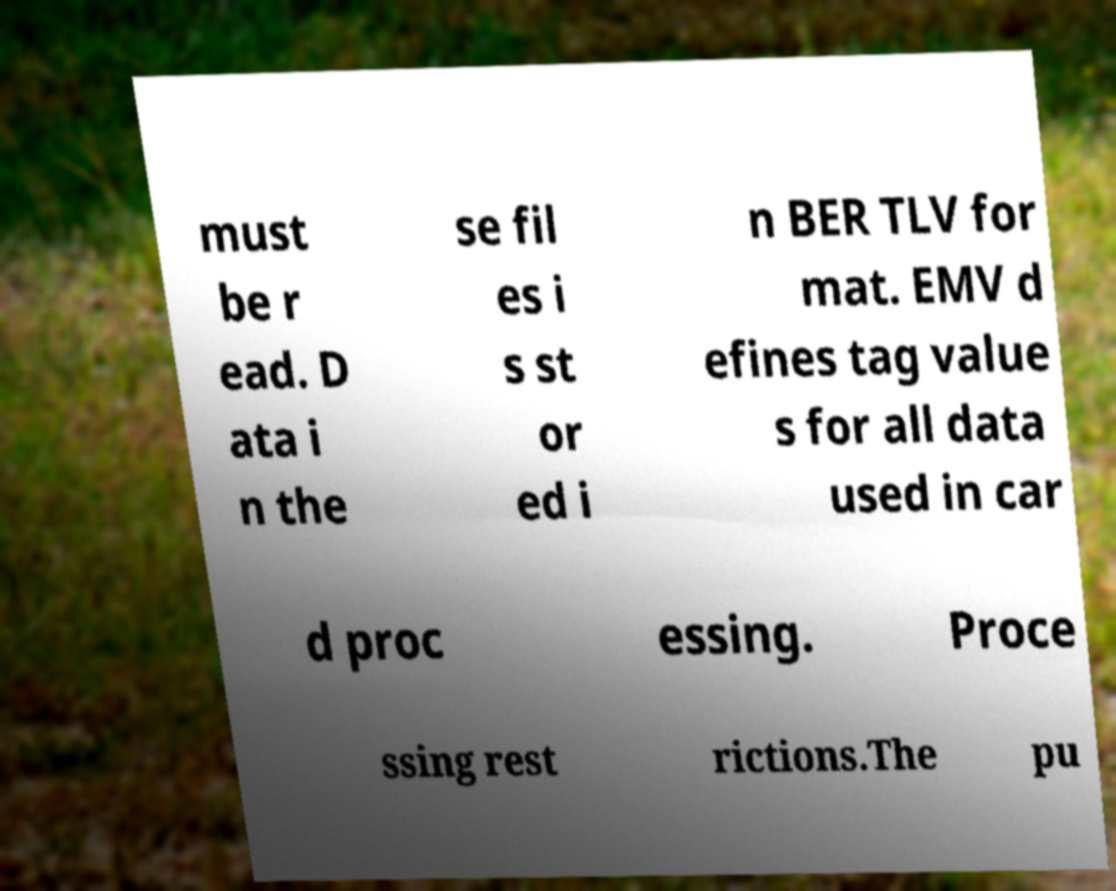Please identify and transcribe the text found in this image. must be r ead. D ata i n the se fil es i s st or ed i n BER TLV for mat. EMV d efines tag value s for all data used in car d proc essing. Proce ssing rest rictions.The pu 